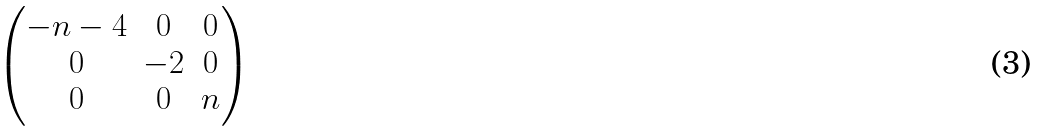<formula> <loc_0><loc_0><loc_500><loc_500>\begin{pmatrix} - n - 4 & 0 & 0 \\ 0 & - 2 & 0 \\ 0 & 0 & n \end{pmatrix}</formula> 